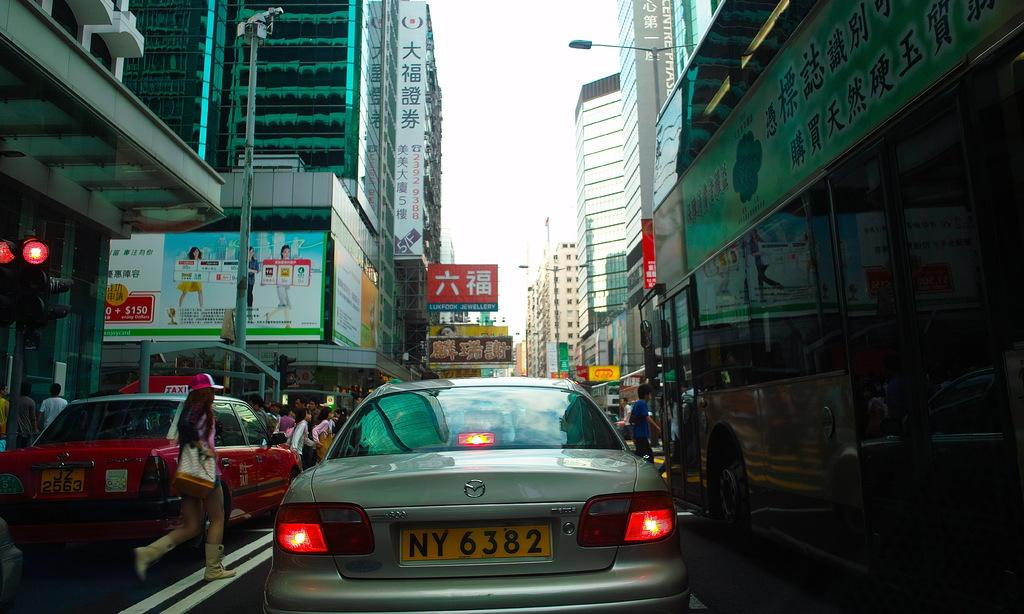<image>
Give a short and clear explanation of the subsequent image. backend of a car on the city street with a licence plate of ny6382 